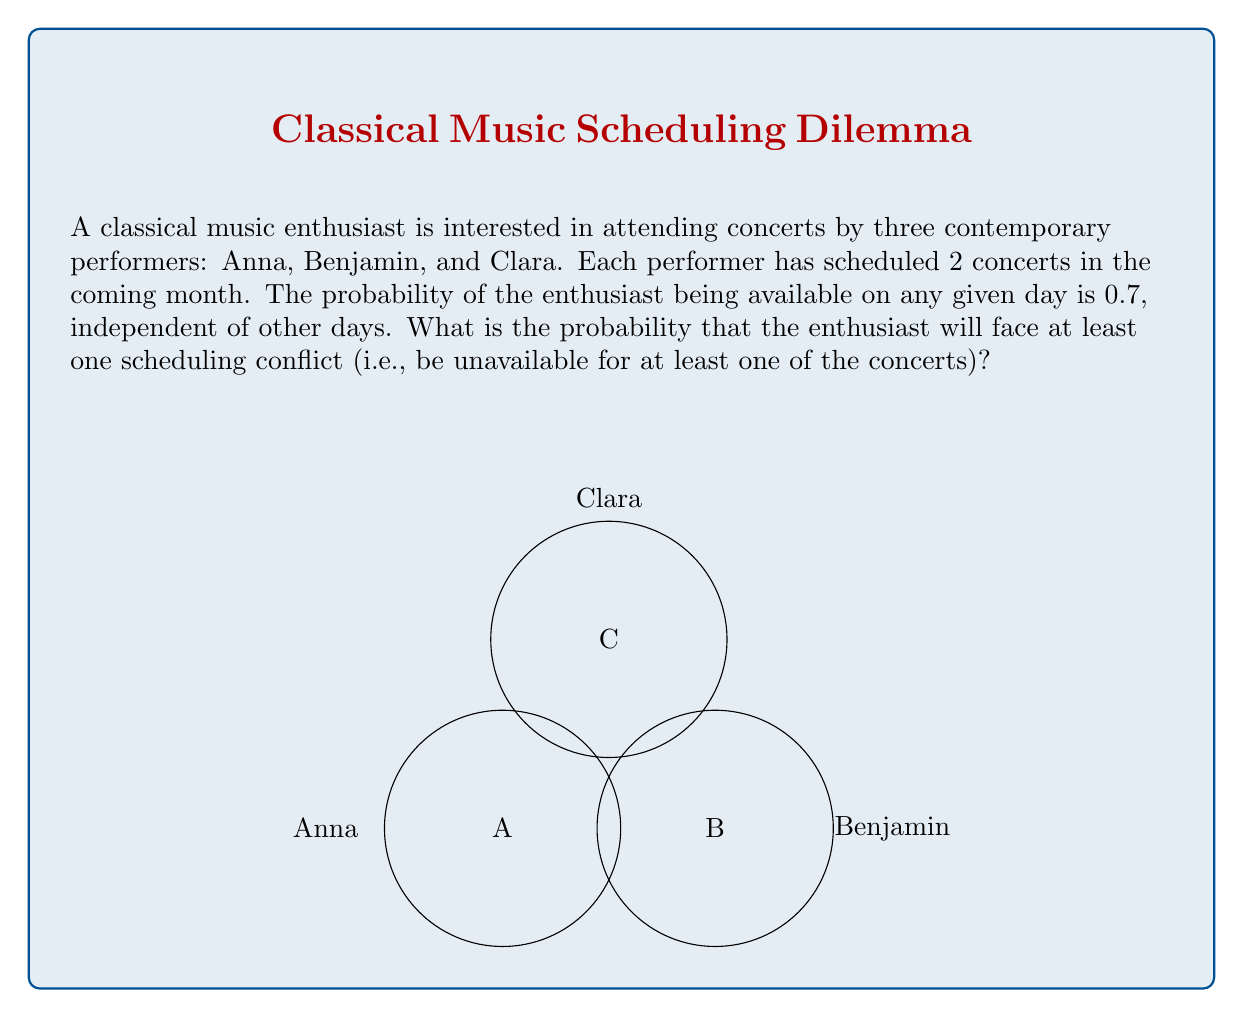Teach me how to tackle this problem. Let's approach this step-by-step:

1) First, let's calculate the probability of being available for all 6 concerts:
   $P(\text{available for all}) = 0.7^6 = 0.1176$

2) Therefore, the probability of facing at least one conflict is the complement of this:
   $P(\text{at least one conflict}) = 1 - P(\text{available for all})$

3) Substituting the value we calculated:
   $P(\text{at least one conflict}) = 1 - 0.1176 = 0.8824$

4) To understand this intuitively:
   - The enthusiast needs to be available for all 6 concerts to avoid any conflict.
   - The probability of this happening is quite low (only about 11.76%).
   - Thus, the probability of facing at least one conflict is quite high (about 88.24%).

5) This high probability makes sense because:
   - There are multiple opportunities for conflicts (6 concerts).
   - The availability probability for each day (0.7) is not extremely high.

Therefore, the probability of facing at least one scheduling conflict is approximately 0.8824 or 88.24%.
Answer: 0.8824 